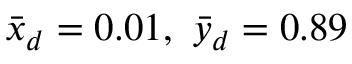Convert formula to latex. <formula><loc_0><loc_0><loc_500><loc_500>\bar { x } _ { d } = 0 . 0 1 , \bar { y } _ { d } = 0 . 8 9</formula> 